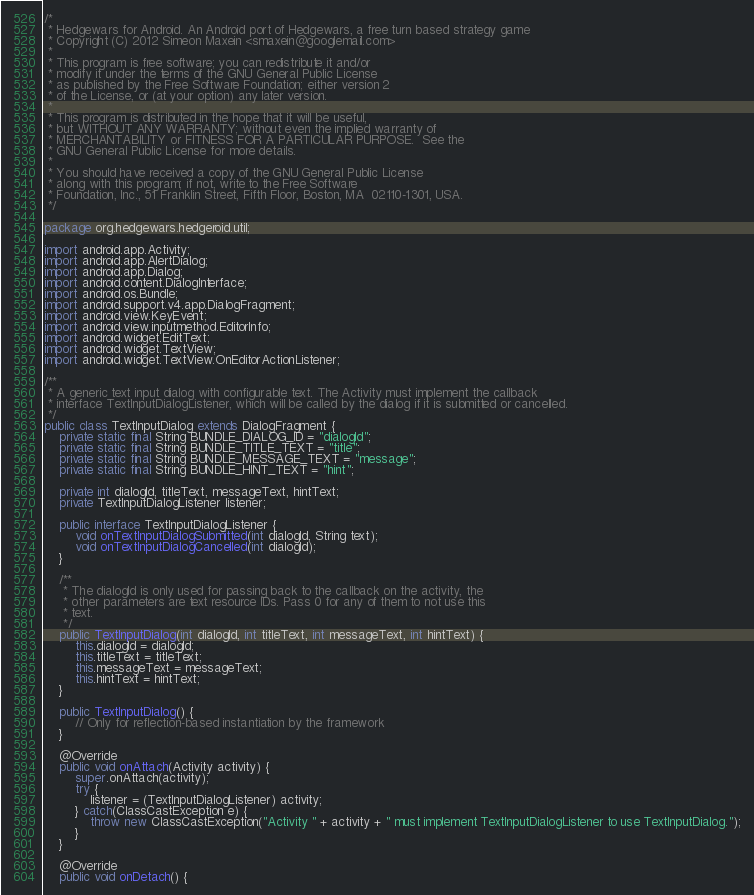<code> <loc_0><loc_0><loc_500><loc_500><_Java_>/*
 * Hedgewars for Android. An Android port of Hedgewars, a free turn based strategy game
 * Copyright (C) 2012 Simeon Maxein <smaxein@googlemail.com>
 *
 * This program is free software; you can redistribute it and/or
 * modify it under the terms of the GNU General Public License
 * as published by the Free Software Foundation; either version 2
 * of the License, or (at your option) any later version.
 *
 * This program is distributed in the hope that it will be useful,
 * but WITHOUT ANY WARRANTY; without even the implied warranty of
 * MERCHANTABILITY or FITNESS FOR A PARTICULAR PURPOSE.  See the
 * GNU General Public License for more details.
 *
 * You should have received a copy of the GNU General Public License
 * along with this program; if not, write to the Free Software
 * Foundation, Inc., 51 Franklin Street, Fifth Floor, Boston, MA  02110-1301, USA.
 */

package org.hedgewars.hedgeroid.util;

import android.app.Activity;
import android.app.AlertDialog;
import android.app.Dialog;
import android.content.DialogInterface;
import android.os.Bundle;
import android.support.v4.app.DialogFragment;
import android.view.KeyEvent;
import android.view.inputmethod.EditorInfo;
import android.widget.EditText;
import android.widget.TextView;
import android.widget.TextView.OnEditorActionListener;

/**
 * A generic text input dialog with configurable text. The Activity must implement the callback
 * interface TextInputDialogListener, which will be called by the dialog if it is submitted or cancelled.
 */
public class TextInputDialog extends DialogFragment {
    private static final String BUNDLE_DIALOG_ID = "dialogId";
    private static final String BUNDLE_TITLE_TEXT = "title";
    private static final String BUNDLE_MESSAGE_TEXT = "message";
    private static final String BUNDLE_HINT_TEXT = "hint";

    private int dialogId, titleText, messageText, hintText;
    private TextInputDialogListener listener;

    public interface TextInputDialogListener {
        void onTextInputDialogSubmitted(int dialogId, String text);
        void onTextInputDialogCancelled(int dialogId);
    }

    /**
     * The dialogId is only used for passing back to the callback on the activity, the
     * other parameters are text resource IDs. Pass 0 for any of them to not use this
     * text.
     */
    public TextInputDialog(int dialogId, int titleText, int messageText, int hintText) {
        this.dialogId = dialogId;
        this.titleText = titleText;
        this.messageText = messageText;
        this.hintText = hintText;
    }

    public TextInputDialog() {
        // Only for reflection-based instantiation by the framework
    }

    @Override
    public void onAttach(Activity activity) {
        super.onAttach(activity);
        try {
            listener = (TextInputDialogListener) activity;
        } catch(ClassCastException e) {
            throw new ClassCastException("Activity " + activity + " must implement TextInputDialogListener to use TextInputDialog.");
        }
    }

    @Override
    public void onDetach() {</code> 